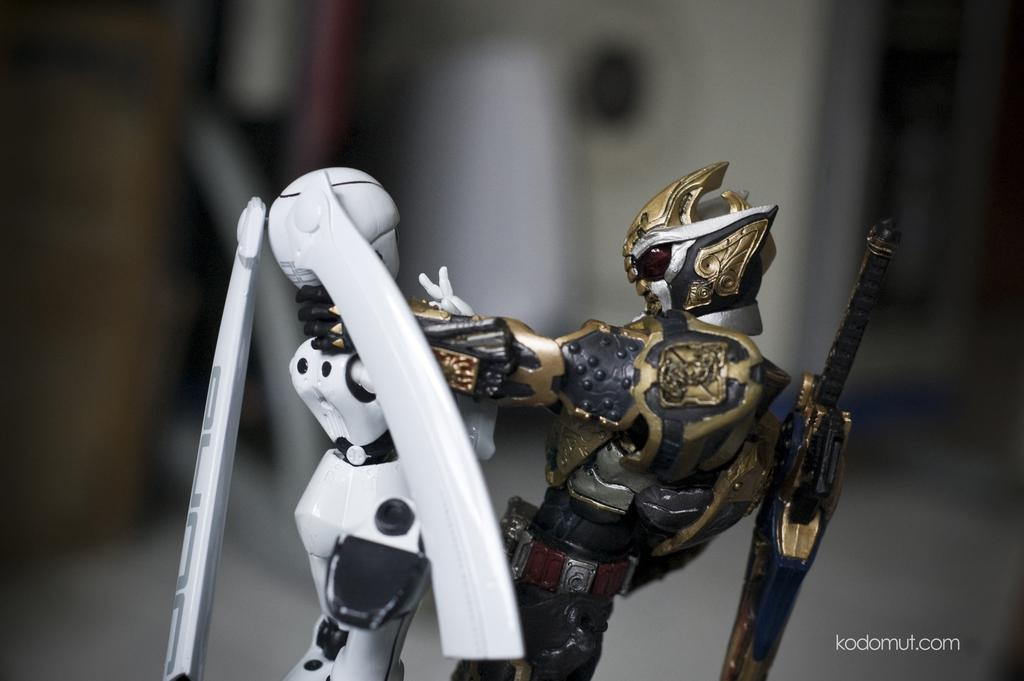How many toys are visible in the image? There are two toys in the image. Can you describe the background of the image? The background of the image is blurry. Where is the text located in the image? The text is in the bottom right side of the image. What type of cave can be seen in the background of the image? There is no cave present in the image; the background is blurry. What is the man doing in the image? There is no man present in the image; it only features two toys and text in the bottom right side. 